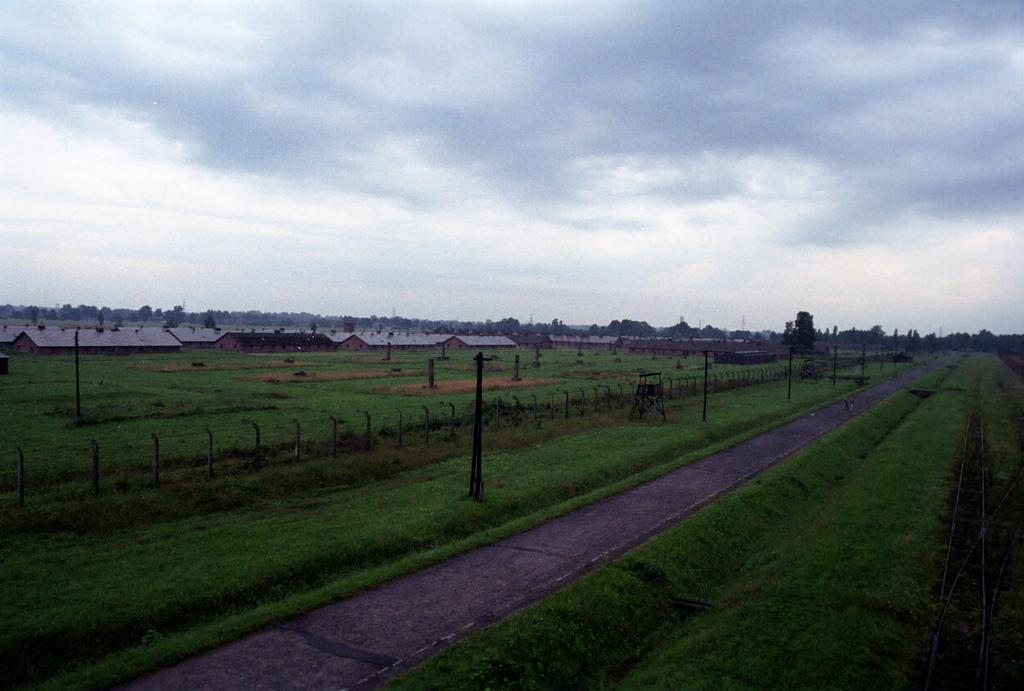What type of structure can be seen in the image? There is a fence in the image. What other objects are present in the image? There are poles, a road, grass, houses, and trees in the image. Can you describe the background of the image? The background of the image includes trees and the sky. What verse is being recited by the ghost in the image? There is no ghost present in the image, so there is no verse being recited. What type of cord is connected to the poles in the image? There is no cord connected to the poles in the image; only poles are mentioned. 